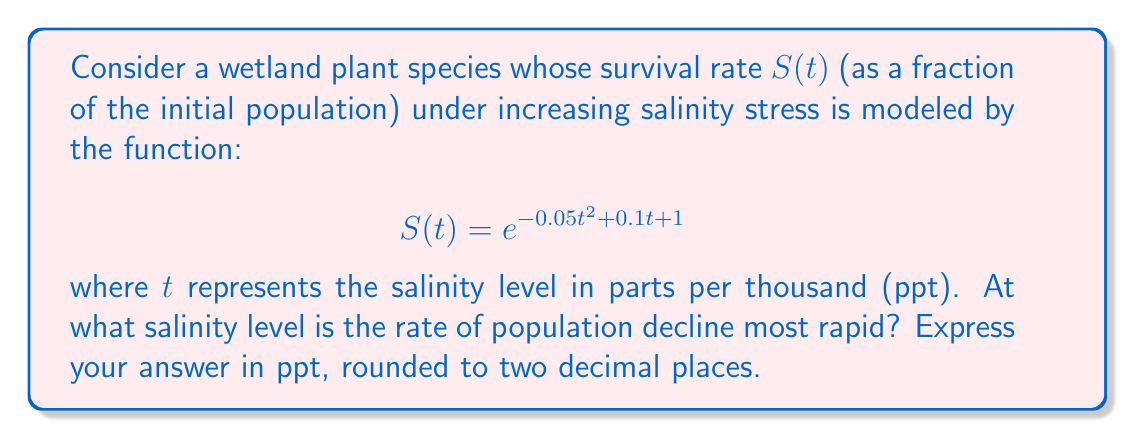Help me with this question. To find the salinity level where the rate of population decline is most rapid, we need to find the minimum value of the derivative of $S(t)$. This will correspond to the steepest negative slope of the survival curve.

1) First, let's calculate the derivative of $S(t)$:

   $$\frac{d}{dt}S(t) = S(t) \cdot \frac{d}{dt}(-0.05t^2 + 0.1t + 1)$$
   $$\frac{d}{dt}S(t) = e^{-0.05t^2 + 0.1t + 1} \cdot (-0.1t + 0.1)$$

2) The rate of decline is most rapid when this derivative is at its minimum (most negative) value. To find this, we need to find where the derivative of this function equals zero:

   $$\frac{d}{dt}\left(\frac{d}{dt}S(t)\right) = e^{-0.05t^2 + 0.1t + 1} \cdot (-0.1) + e^{-0.05t^2 + 0.1t + 1} \cdot (-0.1t + 0.1) \cdot (-0.1t + 0.1) = 0$$

3) Simplifying:

   $$e^{-0.05t^2 + 0.1t + 1} \cdot [-0.1 + (-0.1t + 0.1)^2] = 0$$

4) Since $e^{-0.05t^2 + 0.1t + 1}$ is always positive, we can solve:

   $$-0.1 + (-0.1t + 0.1)^2 = 0$$
   $$(-0.1t + 0.1)^2 = 0.1$$
   $$-0.1t + 0.1 = \pm \sqrt{0.1}$$

5) Solving for t:

   $$-0.1t = \pm \sqrt{0.1} - 0.1$$
   $$t = 1 \mp 10\sqrt{0.1}$$

6) The negative solution doesn't make sense in our context, so we take the positive solution:

   $$t = 1 + 10\sqrt{0.1} \approx 4.16$$

Therefore, the rate of population decline is most rapid when the salinity level is approximately 4.16 ppt.
Answer: 4.16 ppt 